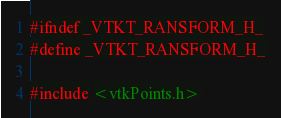Convert code to text. <code><loc_0><loc_0><loc_500><loc_500><_C_>#ifndef _VTKT_RANSFORM_H_
#define _VTKT_RANSFORM_H_

#include <vtkPoints.h></code> 